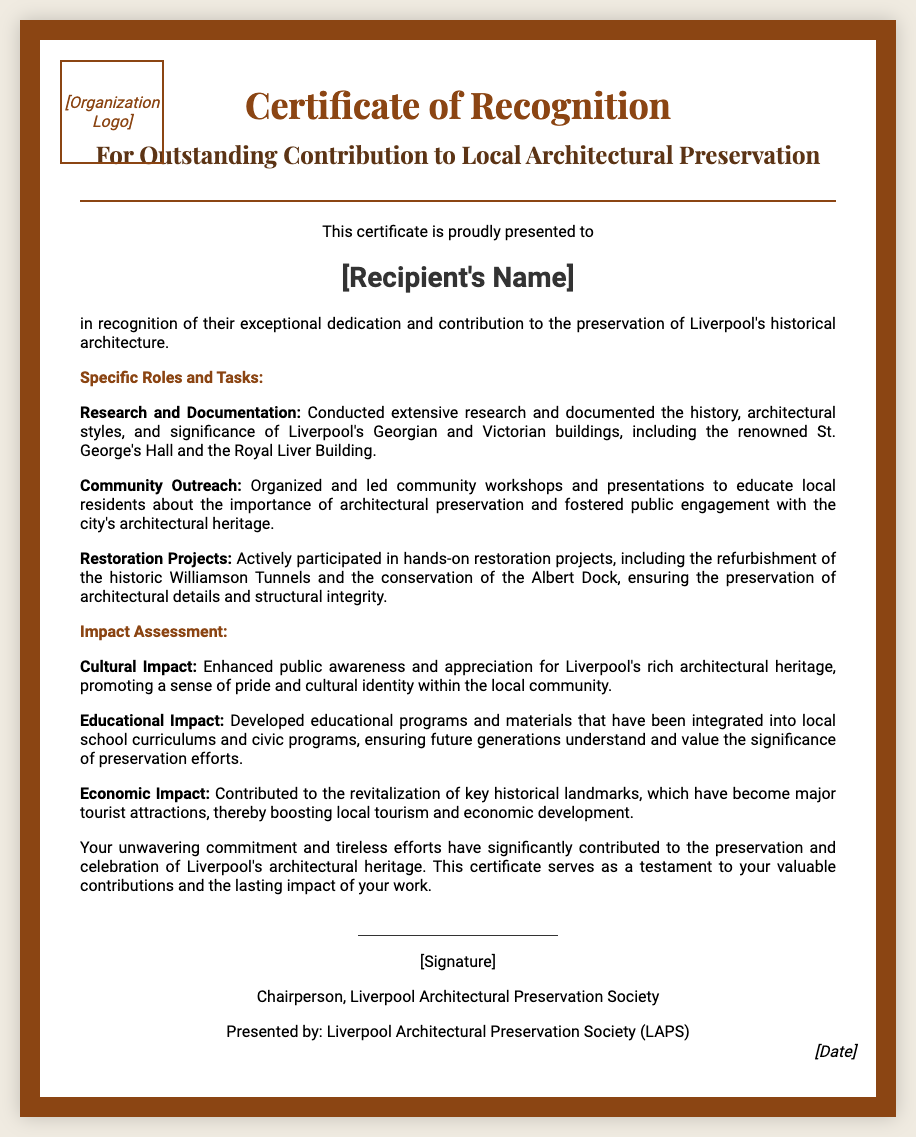What is the title of the certificate? The title of the certificate is prominently displayed at the top of the document.
Answer: Certificate of Recognition Who is the recipient of the certificate? The recipient's name is highlighted in the document for recognition.
Answer: [Recipient's Name] What is one specific role in the tasks outlined? The document lists various tasks, so one can be identified easily.
Answer: Research and Documentation What famous landmark is mentioned as part of the research? The document references significant buildings in Liverpool's history as part of the research tasks.
Answer: St. George's Hall What impact is attributed to the educational initiatives? The document describes the outcomes of various efforts and how they relate to education.
Answer: Developed educational programs What type of projects did the recipient participate in? The document describes the nature of the work done by the recipient in a specific area.
Answer: Restoration Projects What organization presented the certificate? The issuer of the certificate is mentioned at the end of the document.
Answer: Liverpool Architectural Preservation Society (LAPS) What type of impact was primarily discussed in relation to local tourism? The document provides details about various impacts, particularly in economic terms.
Answer: Economic Impact Who signed the certificate? The signature section reveals the identity of the person authorizing the award.
Answer: Chairperson, Liverpool Architectural Preservation Society 